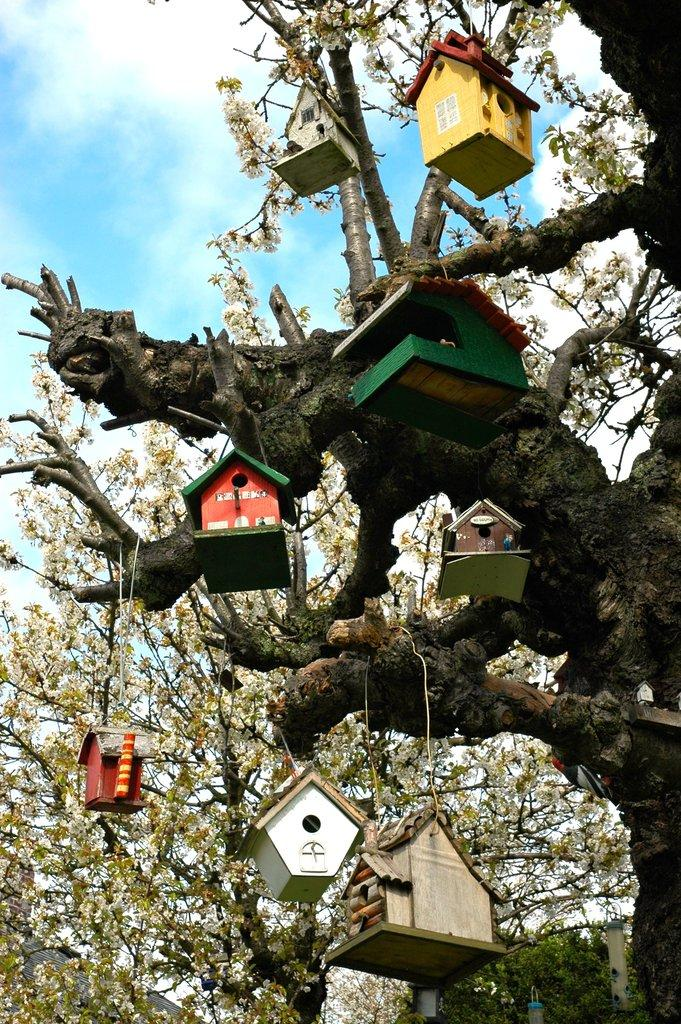What is the main object in the image? There is a tree in the image. What is unique about the tree? There are houses hanging on the tree. What can be seen in the background of the image? Clouds and the sky are visible in the background of the image. What type of war is being fought in the image? There is no war present in the image; it features a tree with houses hanging on it and a background with clouds and the sky. What offer is being made by the tree in the image? The tree is not making any offer in the image; it is simply a tree with houses hanging on it. 